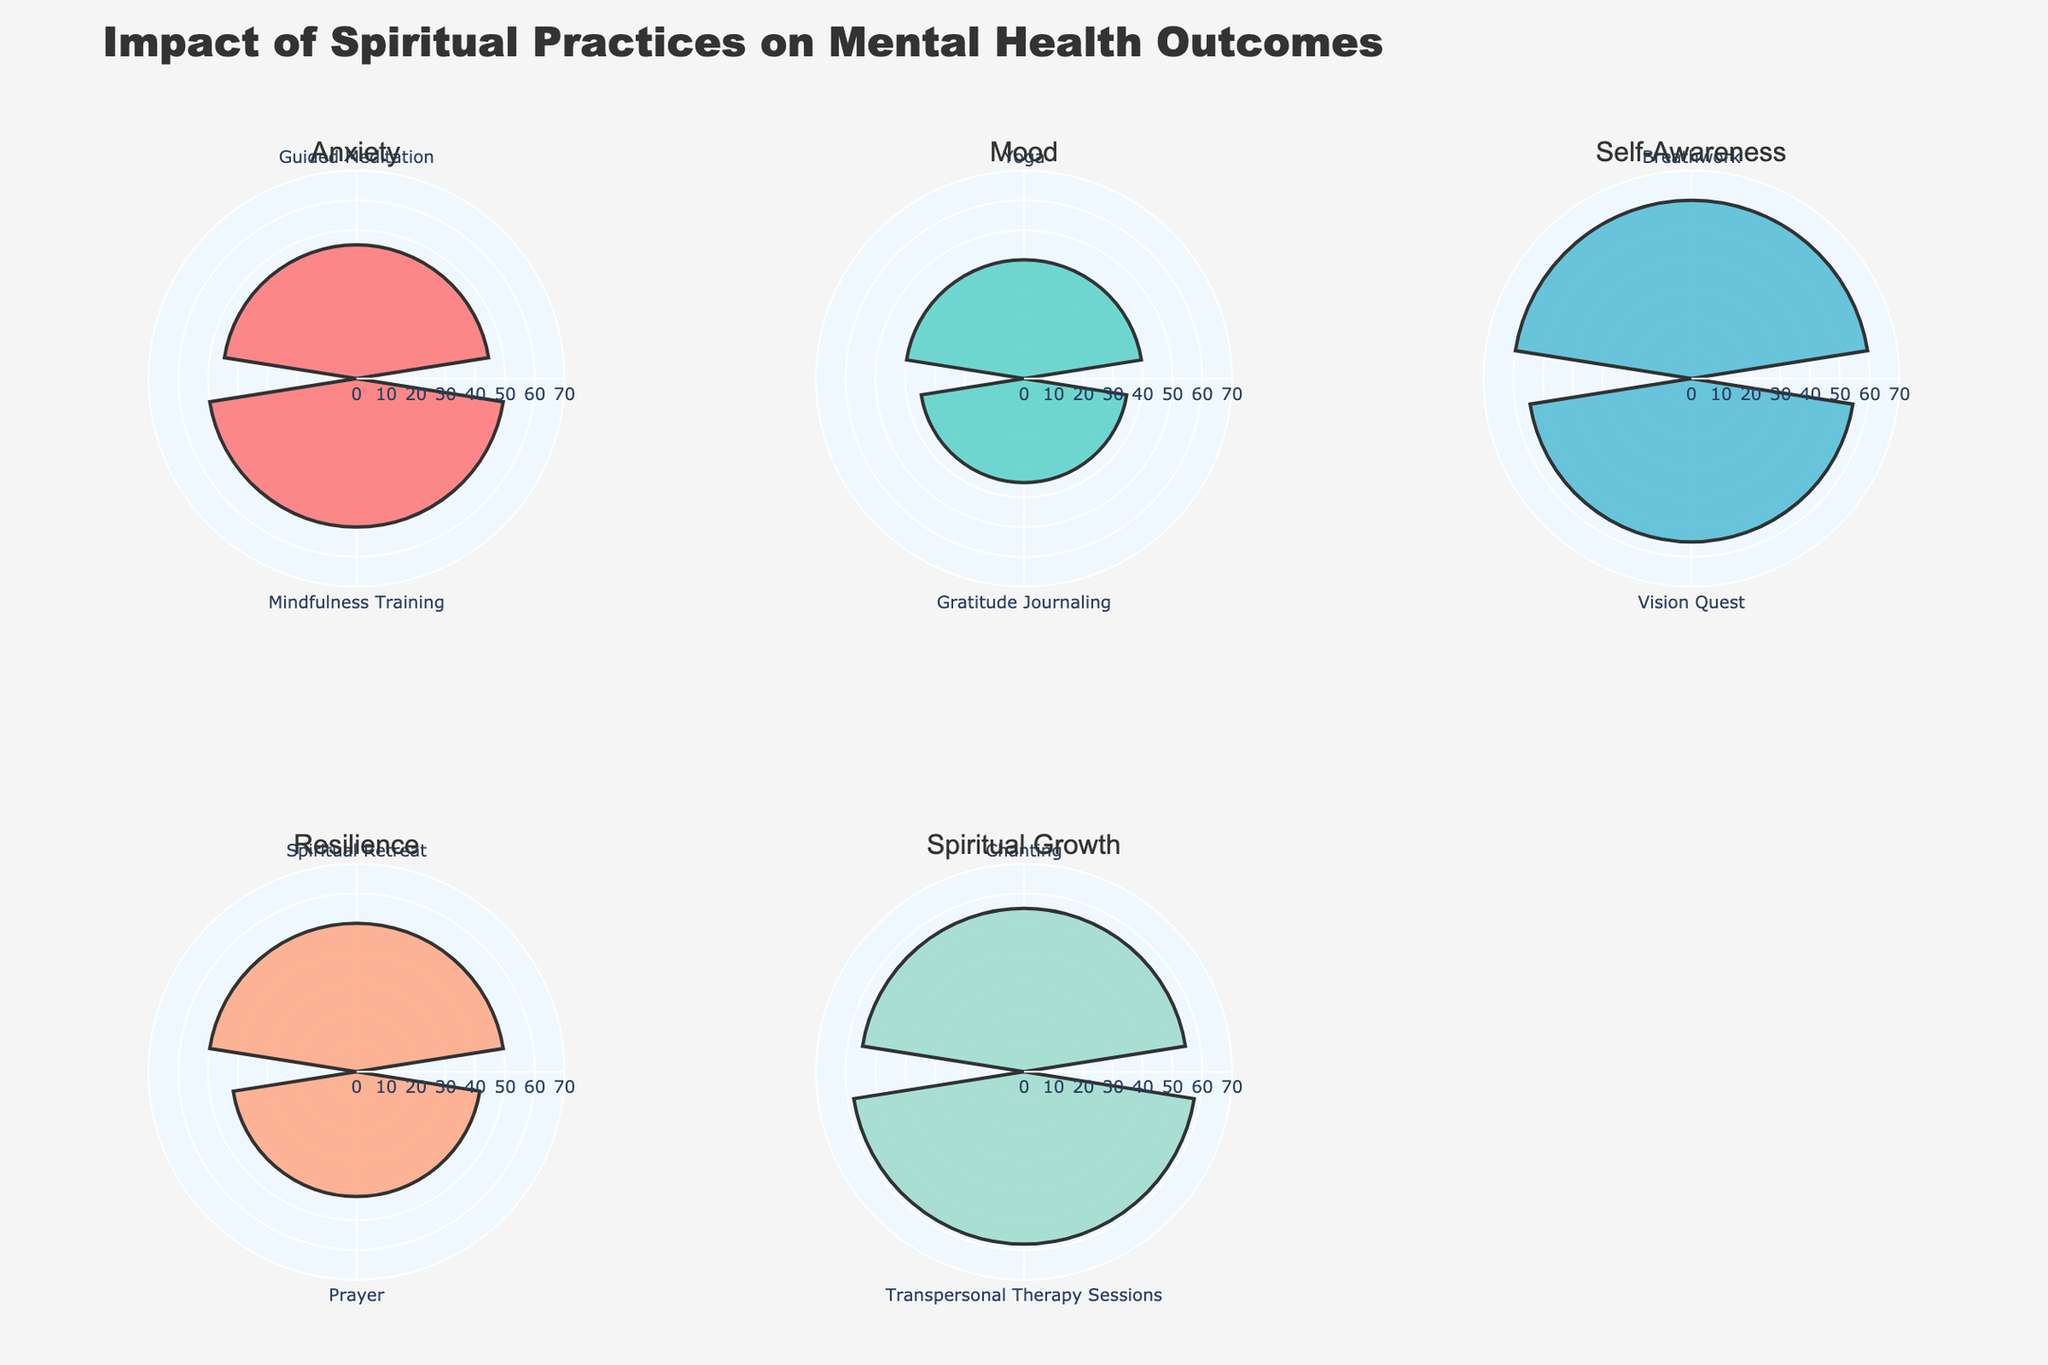What is the title of the figure? The title is displayed at the top of the figure. It reads "Impact of Spiritual Practices on Mental Health Outcomes".
Answer: Impact of Spiritual Practices on Mental Health Outcomes Which intervention has the highest percentage improvement for reduction in anxiety? By examining the first subplot labeled "Anxiety", Guided Meditation shows a 45% improvement, while Mindfulness Training shows a 50% improvement. Thus, Mindfulness Training has the highest percentage improvement for reduction in anxiety.
Answer: Mindfulness Training What is the average percentage improvement in mood for the interventions listed? There are two interventions listed under "Mood": Yoga with 40% and Gratitude Journaling with 35% improvement. The average is calculated as (40 + 35) / 2 = 75 / 2 = 37.5.
Answer: 37.5 Which spiritual practice has the highest impact on self-awareness? In the subplot labeled "Self-Awareness", Breathwork shows an improvement of 60%, while Vision Quest shows 55%. Therefore, Breathwork has the highest impact on self-awareness.
Answer: Breathwork How does the percentage improvement of Prayer in resilience compare to Spiritual Retreat? In the "Resilience" subplot, Prayer shows a 42% improvement, and Spiritual Retreat shows a 50% improvement. Spiritual Retreat has a higher percentage improvement than Prayer.
Answer: Spiritual Retreat What is the color used to represent interventions in the first subplot (Anxiety)? The first subplot for Anxiety uses the color for the interventions, which is likely a specific shade designed for that category. The exact shade is a part of the custom color palette.
Answer: A distinct color from the palette How many interventions are visualized in each subplot? Each subplot represents two interventions for their respective categories, indicated by two bar segments in each rose chart.
Answer: 2 Which intervention in Spiritual Growth has a slightly higher percentage improvement, Chanting or Transpersonal Therapy Sessions? In the "Spiritual Growth" subplot, Chanting has a 55% improvement, while Transpersonal Therapy Sessions have a 58% improvement. Transpersonal Therapy Sessions have a slightly higher improvement.
Answer: Transpersonal Therapy Sessions What is the approximate range set for the radial axis in each polar subplot? The radial axis range is uniform across all subplots and appears to be set up to around 70% based on the visible markings.
Answer: Up to 70% What is the overall trend observed for different spiritual practices in terms of mental health outcomes? By examining the subplots, each category shows various degrees of improvement through different spiritual practices, with each intervention leading to a significant percentage improvement in outcomes, indicating a positive impact across all categories.
Answer: Positive impact across all categories 